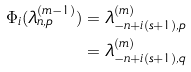Convert formula to latex. <formula><loc_0><loc_0><loc_500><loc_500>\Phi _ { i } ( \lambda _ { n , p } ^ { ( m - 1 ) } ) & = \lambda _ { - n + i ( s + 1 ) , p } ^ { ( m ) } \\ & = \lambda _ { - n + i ( s + 1 ) , q } ^ { ( m ) }</formula> 